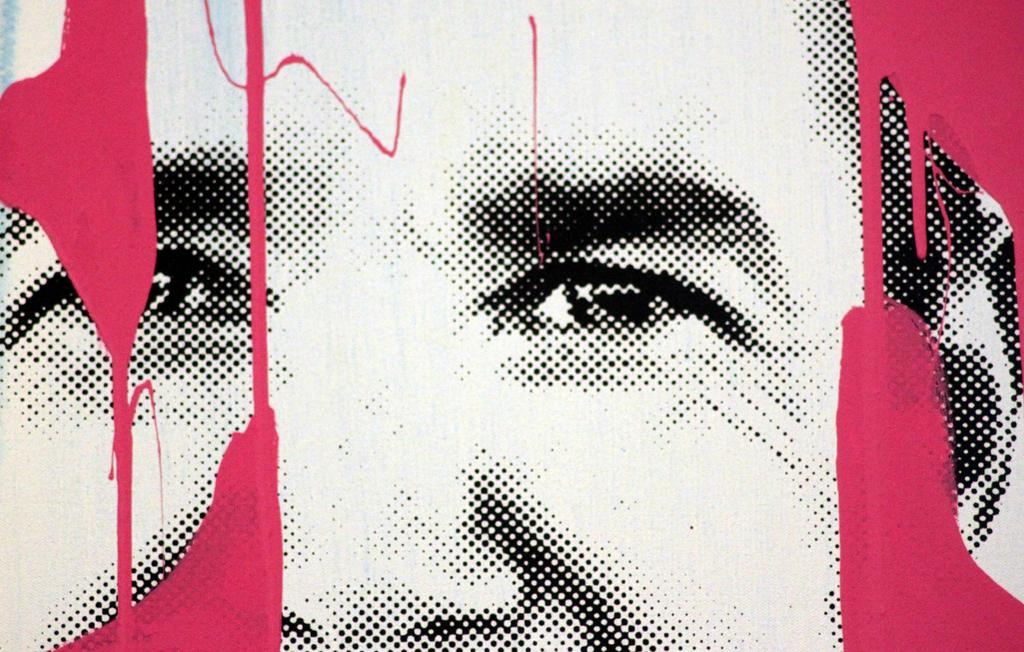What is the main subject of the image? There is a depiction of a person's face in the image. Can you describe any specific features of the face? The provided facts do not mention any specific features of the face. What colors are present on the sides of the image? There are red color marks on both sides of the image. Can you tell me how many giraffes are standing behind the person in the image? There are no giraffes present in the image; it only features a depiction of a person's face. What type of cake is being prepared by the cook in the image? There is no cook or cake present in the image; it only features a depiction of a person's face and red color marks on the sides. 